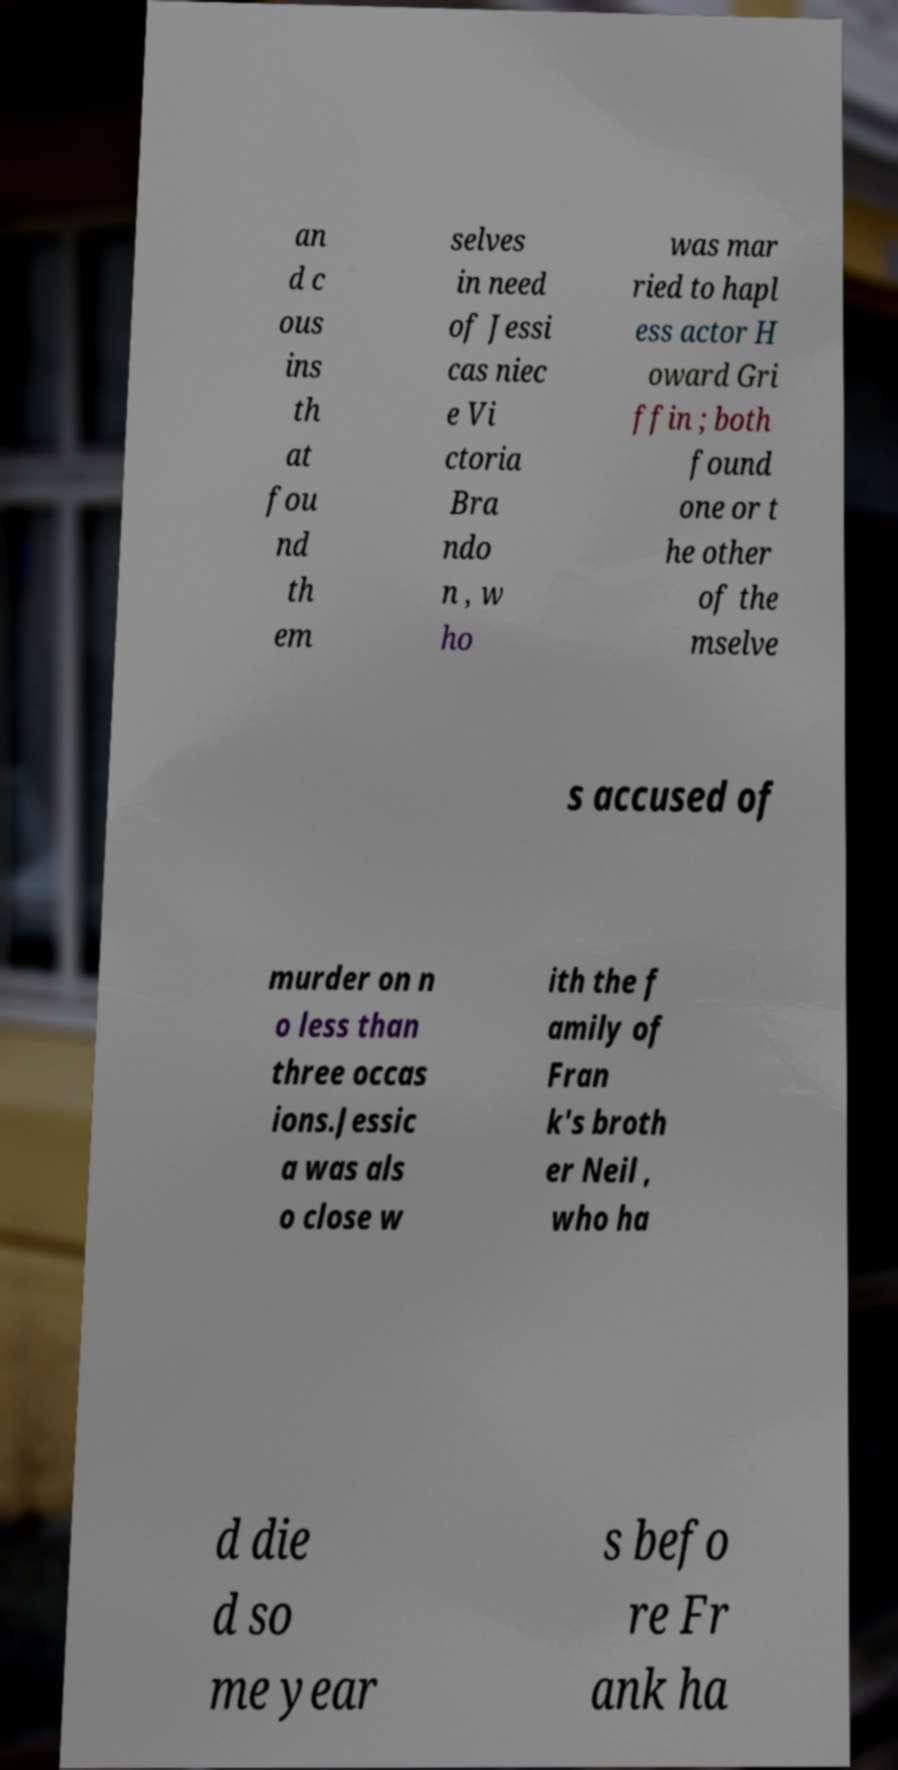Can you accurately transcribe the text from the provided image for me? an d c ous ins th at fou nd th em selves in need of Jessi cas niec e Vi ctoria Bra ndo n , w ho was mar ried to hapl ess actor H oward Gri ffin ; both found one or t he other of the mselve s accused of murder on n o less than three occas ions.Jessic a was als o close w ith the f amily of Fran k's broth er Neil , who ha d die d so me year s befo re Fr ank ha 